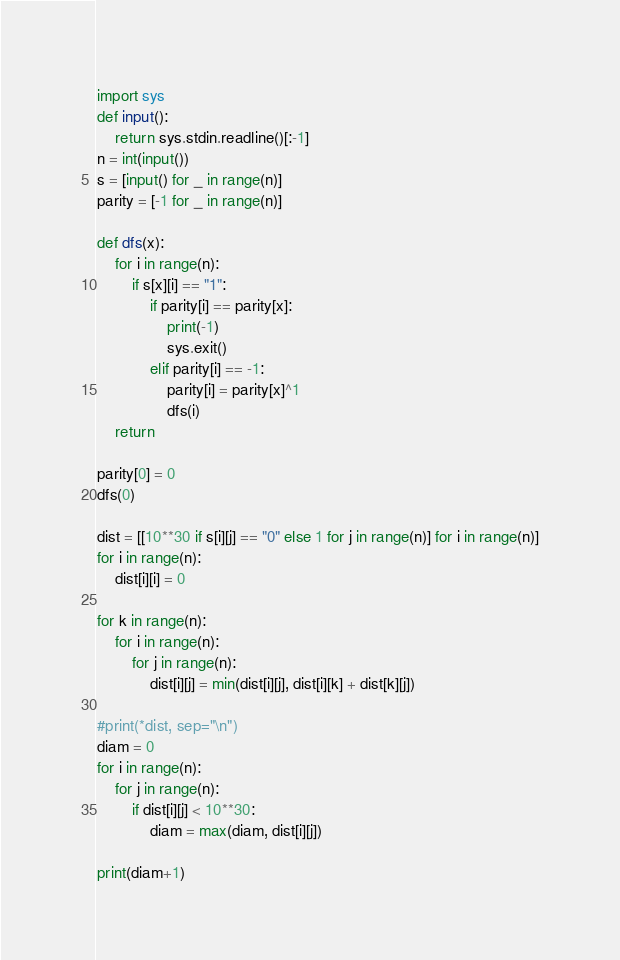<code> <loc_0><loc_0><loc_500><loc_500><_Python_>import sys
def input():
	return sys.stdin.readline()[:-1]
n = int(input())
s = [input() for _ in range(n)]
parity = [-1 for _ in range(n)]

def dfs(x):
	for i in range(n):
		if s[x][i] == "1":
			if parity[i] == parity[x]:
				print(-1)
				sys.exit()
			elif parity[i] == -1:
				parity[i] = parity[x]^1
				dfs(i)
	return

parity[0] = 0
dfs(0)

dist = [[10**30 if s[i][j] == "0" else 1 for j in range(n)] for i in range(n)]
for i in range(n):
	dist[i][i] = 0

for k in range(n):
	for i in range(n):
		for j in range(n):
			dist[i][j] = min(dist[i][j], dist[i][k] + dist[k][j])

#print(*dist, sep="\n")
diam = 0
for i in range(n):
	for j in range(n):
		if dist[i][j] < 10**30:
			diam = max(diam, dist[i][j])

print(diam+1)</code> 